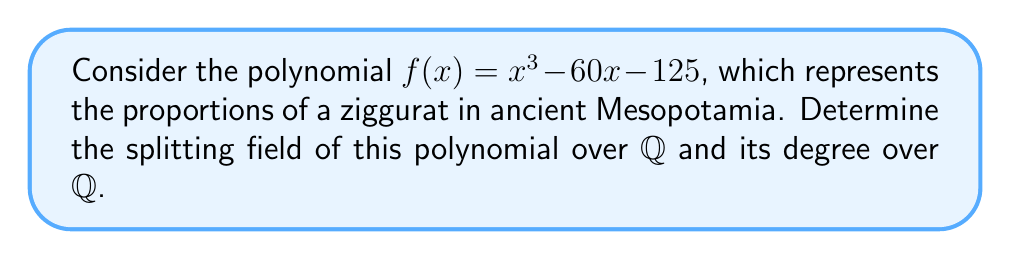Teach me how to tackle this problem. To find the splitting field and its degree, we'll follow these steps:

1) First, we need to factor the polynomial. Let's check if it has any rational roots using the rational root theorem. The possible rational roots are divisors of 125: ±1, ±5, ±25, ±125. Testing these, we find that 5 is a root.

2) Dividing $f(x)$ by $(x-5)$, we get:
   $f(x) = (x-5)(x^2+5x+25)$

3) The quadratic factor $x^2+5x+25$ has no rational roots. Its discriminant is:
   $\Delta = 5^2 - 4(1)(25) = 25 - 100 = -75$

4) Since the discriminant is negative, the quadratic factor has two complex conjugate roots. Let's call them $\alpha$ and $\bar{\alpha}$.

5) The splitting field $K$ will be $\mathbb{Q}(\alpha)$, as it will contain 5, $\alpha$, and $\bar{\alpha}$.

6) To find the degree of $K$ over $\mathbb{Q}$, we need to find the minimal polynomial of $\alpha$ over $\mathbb{Q}$. This is the irreducible quadratic factor $x^2+5x+25$.

7) Therefore, $[\mathbb{Q}(\alpha):\mathbb{Q}] = 2$

Thus, the splitting field is $K = \mathbb{Q}(\alpha)$ where $\alpha$ is a root of $x^2+5x+25$, and its degree over $\mathbb{Q}$ is 2.
Answer: $K = \mathbb{Q}(\alpha)$, $[K:\mathbb{Q}] = 2$ 